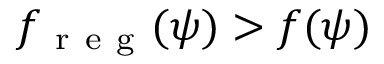Convert formula to latex. <formula><loc_0><loc_0><loc_500><loc_500>f _ { r e g } ( \psi ) > f ( \psi )</formula> 